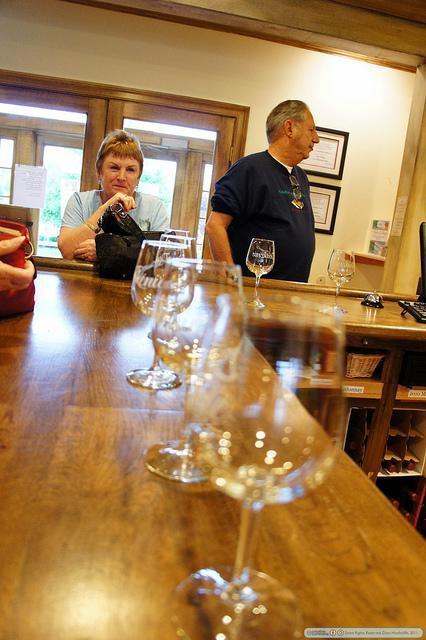How many wine glasses are in the photo?
Give a very brief answer. 3. How many people are in the photo?
Give a very brief answer. 2. How many sinks are visible?
Give a very brief answer. 0. 